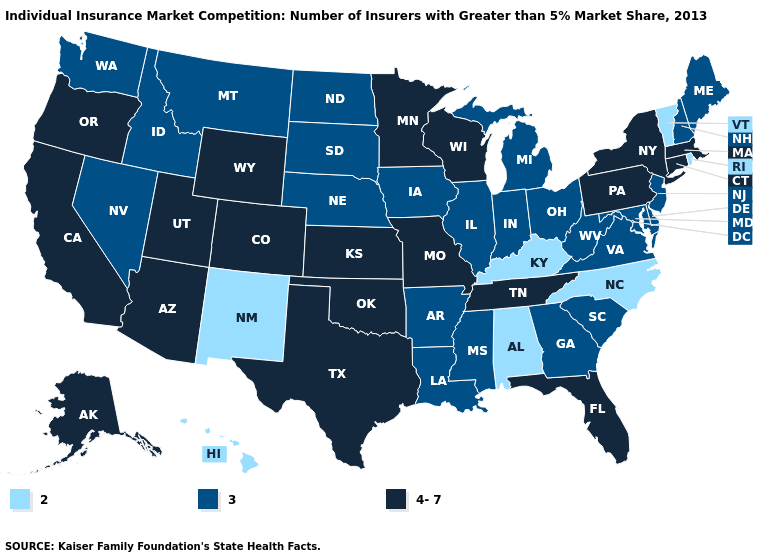Name the states that have a value in the range 4-7?
Keep it brief. Alaska, Arizona, California, Colorado, Connecticut, Florida, Kansas, Massachusetts, Minnesota, Missouri, New York, Oklahoma, Oregon, Pennsylvania, Tennessee, Texas, Utah, Wisconsin, Wyoming. Does New Mexico have the lowest value in the USA?
Quick response, please. Yes. Among the states that border New Hampshire , does Vermont have the highest value?
Give a very brief answer. No. Among the states that border New York , which have the lowest value?
Give a very brief answer. Vermont. Among the states that border Alabama , which have the lowest value?
Give a very brief answer. Georgia, Mississippi. What is the lowest value in the MidWest?
Be succinct. 3. Name the states that have a value in the range 4-7?
Short answer required. Alaska, Arizona, California, Colorado, Connecticut, Florida, Kansas, Massachusetts, Minnesota, Missouri, New York, Oklahoma, Oregon, Pennsylvania, Tennessee, Texas, Utah, Wisconsin, Wyoming. Does Pennsylvania have the lowest value in the Northeast?
Quick response, please. No. Name the states that have a value in the range 3?
Answer briefly. Arkansas, Delaware, Georgia, Idaho, Illinois, Indiana, Iowa, Louisiana, Maine, Maryland, Michigan, Mississippi, Montana, Nebraska, Nevada, New Hampshire, New Jersey, North Dakota, Ohio, South Carolina, South Dakota, Virginia, Washington, West Virginia. What is the value of Rhode Island?
Give a very brief answer. 2. What is the highest value in states that border Indiana?
Keep it brief. 3. Name the states that have a value in the range 4-7?
Concise answer only. Alaska, Arizona, California, Colorado, Connecticut, Florida, Kansas, Massachusetts, Minnesota, Missouri, New York, Oklahoma, Oregon, Pennsylvania, Tennessee, Texas, Utah, Wisconsin, Wyoming. Which states have the highest value in the USA?
Keep it brief. Alaska, Arizona, California, Colorado, Connecticut, Florida, Kansas, Massachusetts, Minnesota, Missouri, New York, Oklahoma, Oregon, Pennsylvania, Tennessee, Texas, Utah, Wisconsin, Wyoming. What is the highest value in states that border Connecticut?
Give a very brief answer. 4-7. Which states hav the highest value in the South?
Be succinct. Florida, Oklahoma, Tennessee, Texas. 